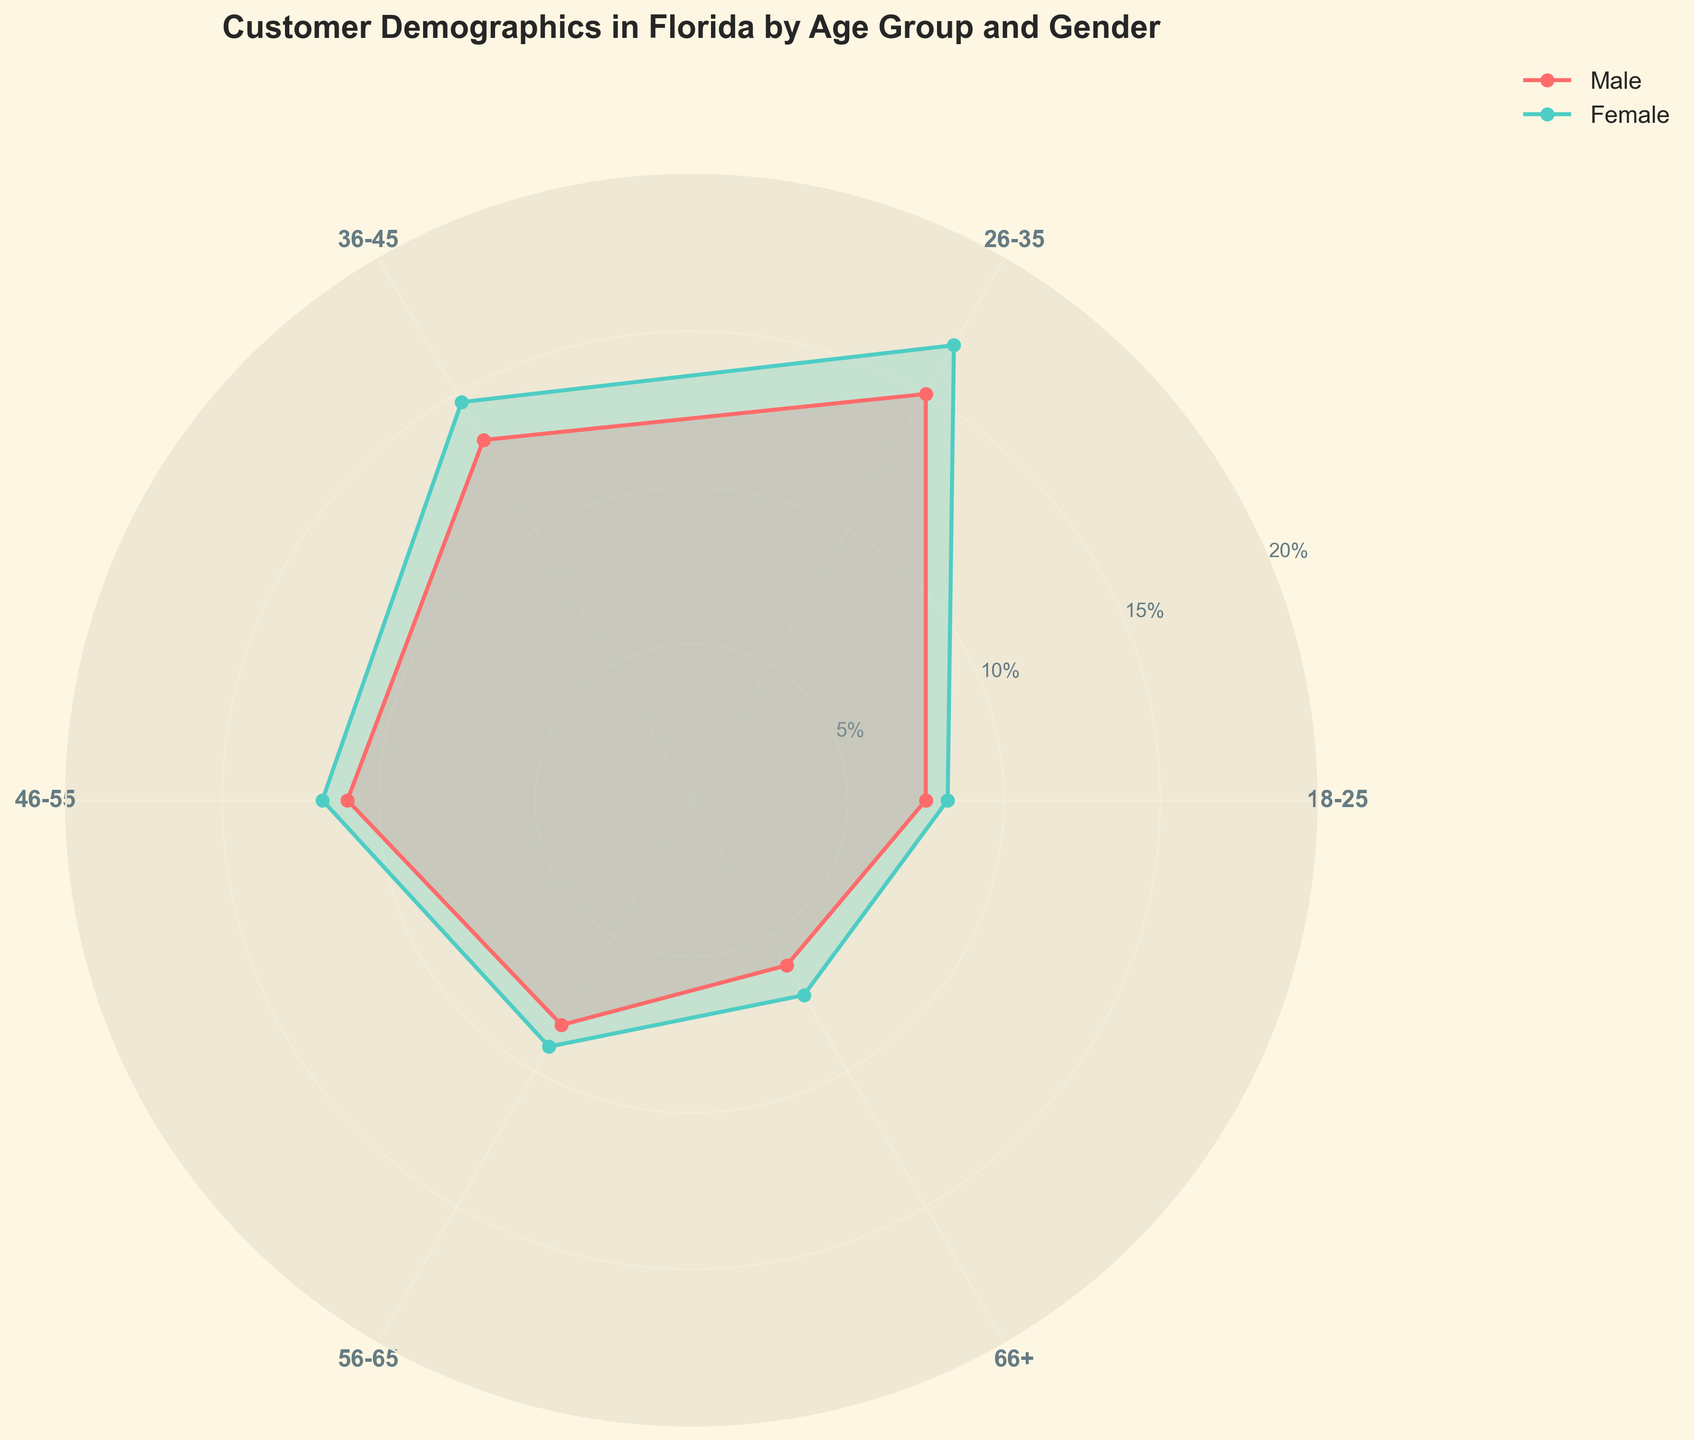How many age groups are represented in the chart? The chart has labels for various age groups visible along the polar axes. Counting them, we see 6 age groups.
Answer: 6 Which gender has a higher percentage in the 26-35 age group? Looking at the polar area sections corresponding to the 26-35 age group, the female segment extends further out than the male segment.
Answer: Female What is the percentage range displayed on the radial axis? The radial axis shows tick marks and labels. They range from 5% to 20%, as shown by the concentric circles.
Answer: 5% to 20% Which age group shows the smallest difference in percentages between males and females? To find this, we calculate the difference between male and female percentages for each age group. The smallest difference is in the 18-25 age group with a difference of 0.7% (8.2% - 7.5%).
Answer: 18-25 What is the average percentage for the age group 36-45? Calculate the average of 13.3% (Male) and 14.7% (Female): (13.3 + 14.7) / 2 = 14.0%
Answer: 14.0% Which age group has the highest percentage of females? The furthest segment for females is the 26-35 age group, at 16.8%.
Answer: 26-35 What's the difference in percentage between males and females in the 56-65 age group? Subtract the male percentage from the female percentage for the 56-65 age group. 9.1% (Female) - 8.3% (Male) = 0.8%.
Answer: 0.8% Which age group has the highest total percentage when combining both genders? Add male and female percentages for each age group. The highest combined percentage is in the 26-35 age group (15.0 + 16.8 = 31.8%).
Answer: 26-35 What can you say about the age group 66+ in terms of gender distribution? Comparing the lengths of the corresponding sections for males and females, females have a higher percentage than males in the age group 66+.
Answer: Females have a higher percentage Which gender shows more variation across the different age groups? Examine the range of percentages across all age groups for both genders. Males range from 6.1% to 15.0% (8.9%), while females range from 7.2% to 16.8% (9.6%). Females show more variation.
Answer: Female 